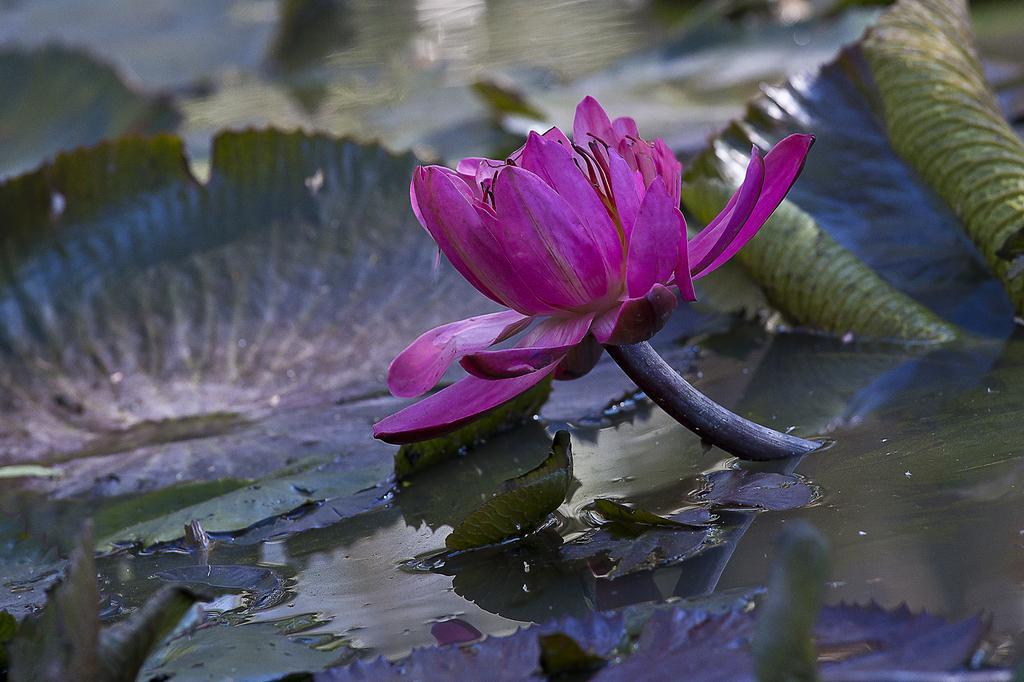Can you describe this image briefly? In this image we can see a pink color lotus, leaves and some water body. In the background image is in a blur. 